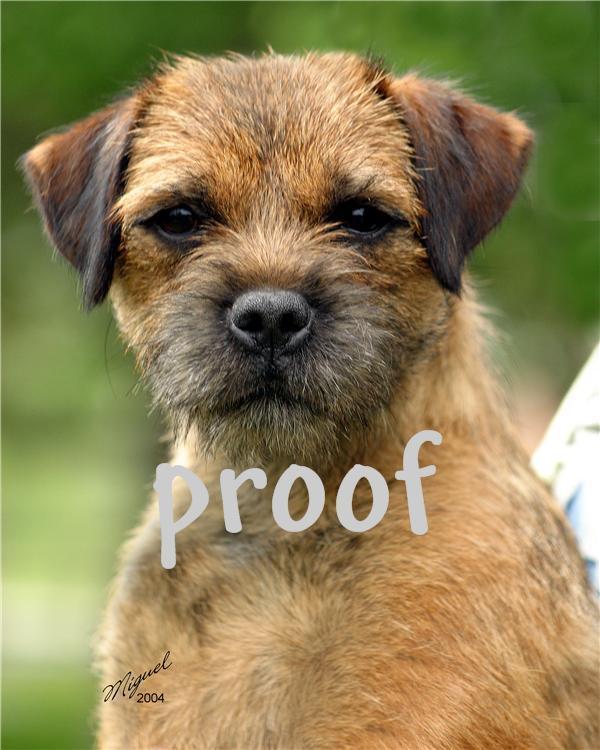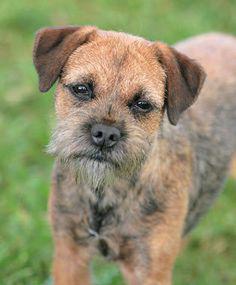The first image is the image on the left, the second image is the image on the right. For the images shown, is this caption "the dog in the image on the right is standing on all fours" true? Answer yes or no. Yes. 